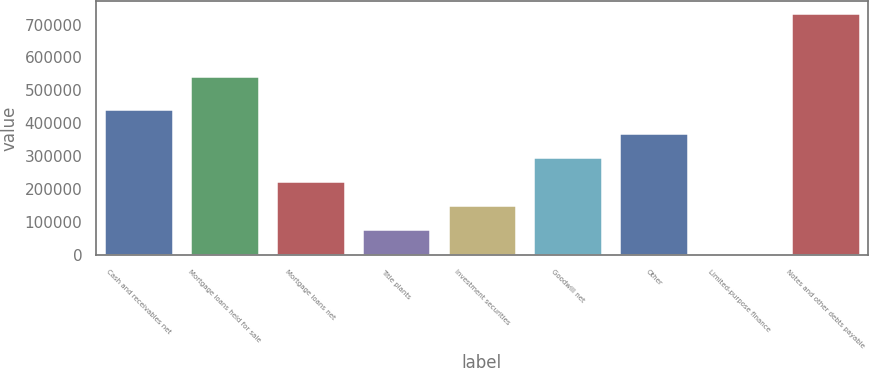Convert chart. <chart><loc_0><loc_0><loc_500><loc_500><bar_chart><fcel>Cash and receivables net<fcel>Mortgage loans held for sale<fcel>Mortgage loans net<fcel>Title plants<fcel>Investment securities<fcel>Goodwill net<fcel>Other<fcel>Limited-purpose finance<fcel>Notes and other debts payable<nl><fcel>443119<fcel>542507<fcel>224466<fcel>78696.5<fcel>151581<fcel>297350<fcel>370234<fcel>5812<fcel>734657<nl></chart> 